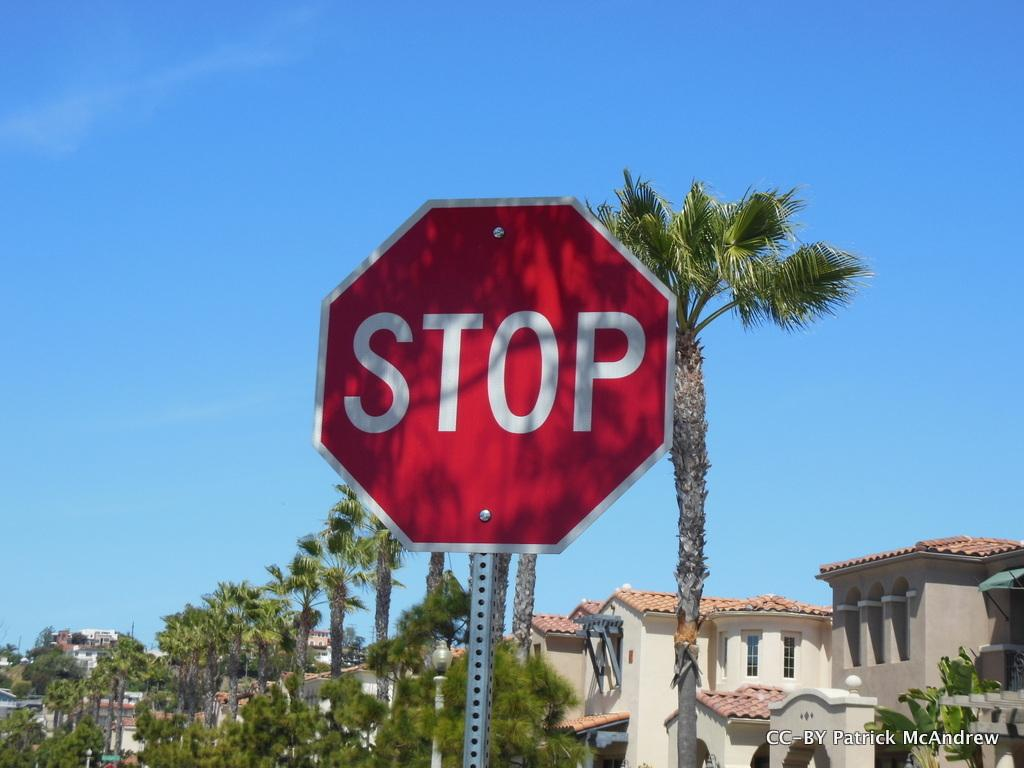Provide a one-sentence caption for the provided image. Patrick McAndrew has documented a red stop sign. 